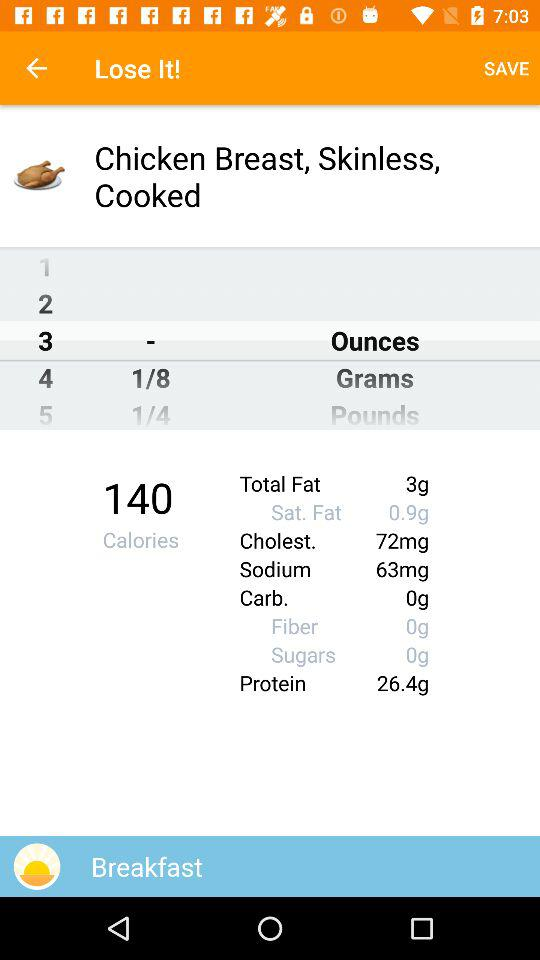How much sodium is there? There is 63 mg of sodium. 